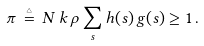Convert formula to latex. <formula><loc_0><loc_0><loc_500><loc_500>\pi \, \stackrel { \triangle } { = } \, N \, k \, \rho \sum _ { s } h ( s ) \, g ( s ) \geq 1 \, .</formula> 